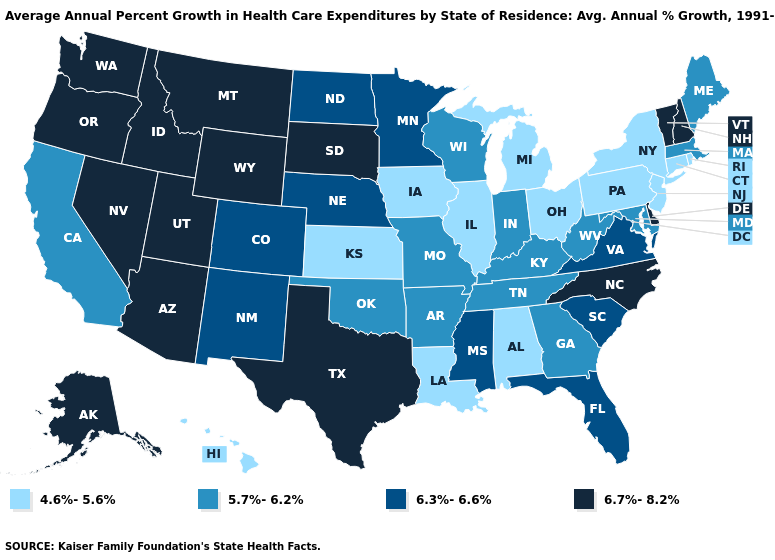What is the value of Nebraska?
Concise answer only. 6.3%-6.6%. Which states have the lowest value in the MidWest?
Answer briefly. Illinois, Iowa, Kansas, Michigan, Ohio. What is the value of Hawaii?
Give a very brief answer. 4.6%-5.6%. What is the highest value in the MidWest ?
Answer briefly. 6.7%-8.2%. Does the first symbol in the legend represent the smallest category?
Concise answer only. Yes. What is the value of Wisconsin?
Quick response, please. 5.7%-6.2%. Name the states that have a value in the range 6.7%-8.2%?
Be succinct. Alaska, Arizona, Delaware, Idaho, Montana, Nevada, New Hampshire, North Carolina, Oregon, South Dakota, Texas, Utah, Vermont, Washington, Wyoming. Which states have the highest value in the USA?
Keep it brief. Alaska, Arizona, Delaware, Idaho, Montana, Nevada, New Hampshire, North Carolina, Oregon, South Dakota, Texas, Utah, Vermont, Washington, Wyoming. Does Connecticut have the same value as Pennsylvania?
Concise answer only. Yes. Name the states that have a value in the range 6.3%-6.6%?
Quick response, please. Colorado, Florida, Minnesota, Mississippi, Nebraska, New Mexico, North Dakota, South Carolina, Virginia. What is the value of Colorado?
Give a very brief answer. 6.3%-6.6%. Among the states that border Indiana , which have the lowest value?
Quick response, please. Illinois, Michigan, Ohio. Among the states that border Texas , does Louisiana have the lowest value?
Quick response, please. Yes. Does Montana have the highest value in the USA?
Answer briefly. Yes. Among the states that border Pennsylvania , does Delaware have the highest value?
Be succinct. Yes. 